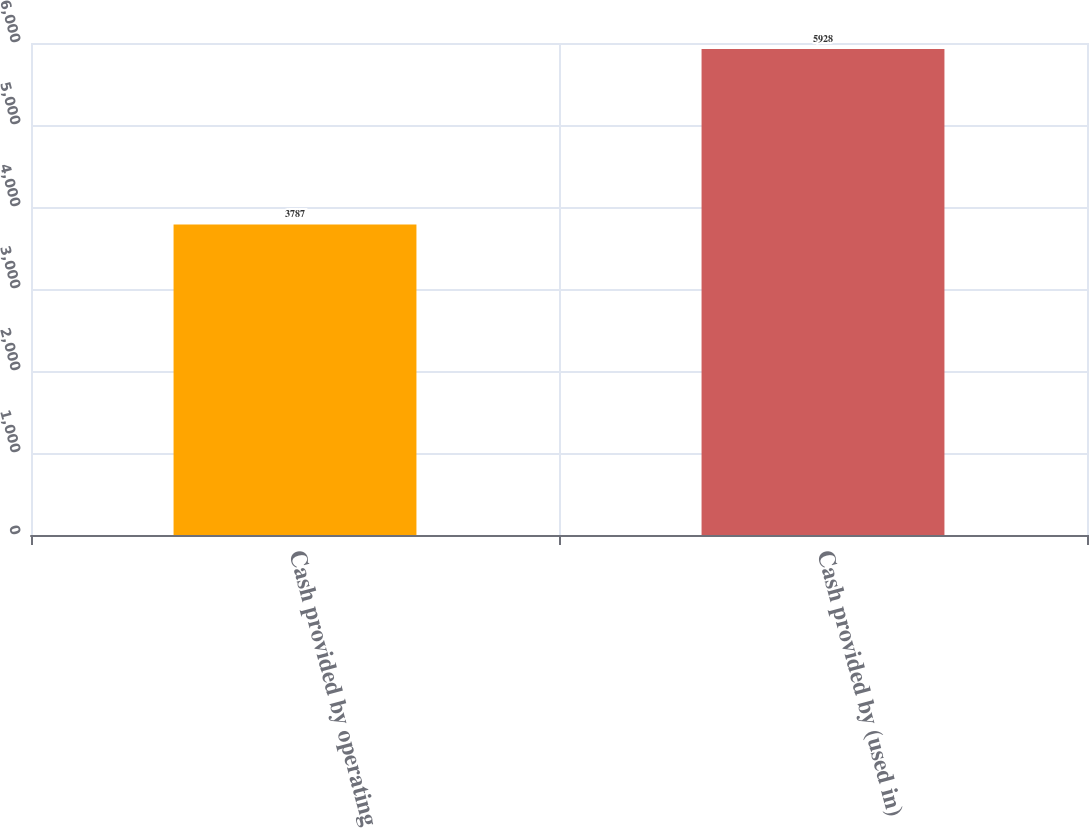Convert chart. <chart><loc_0><loc_0><loc_500><loc_500><bar_chart><fcel>Cash provided by operating<fcel>Cash provided by (used in)<nl><fcel>3787<fcel>5928<nl></chart> 